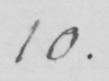Please transcribe the handwritten text in this image. 10. 